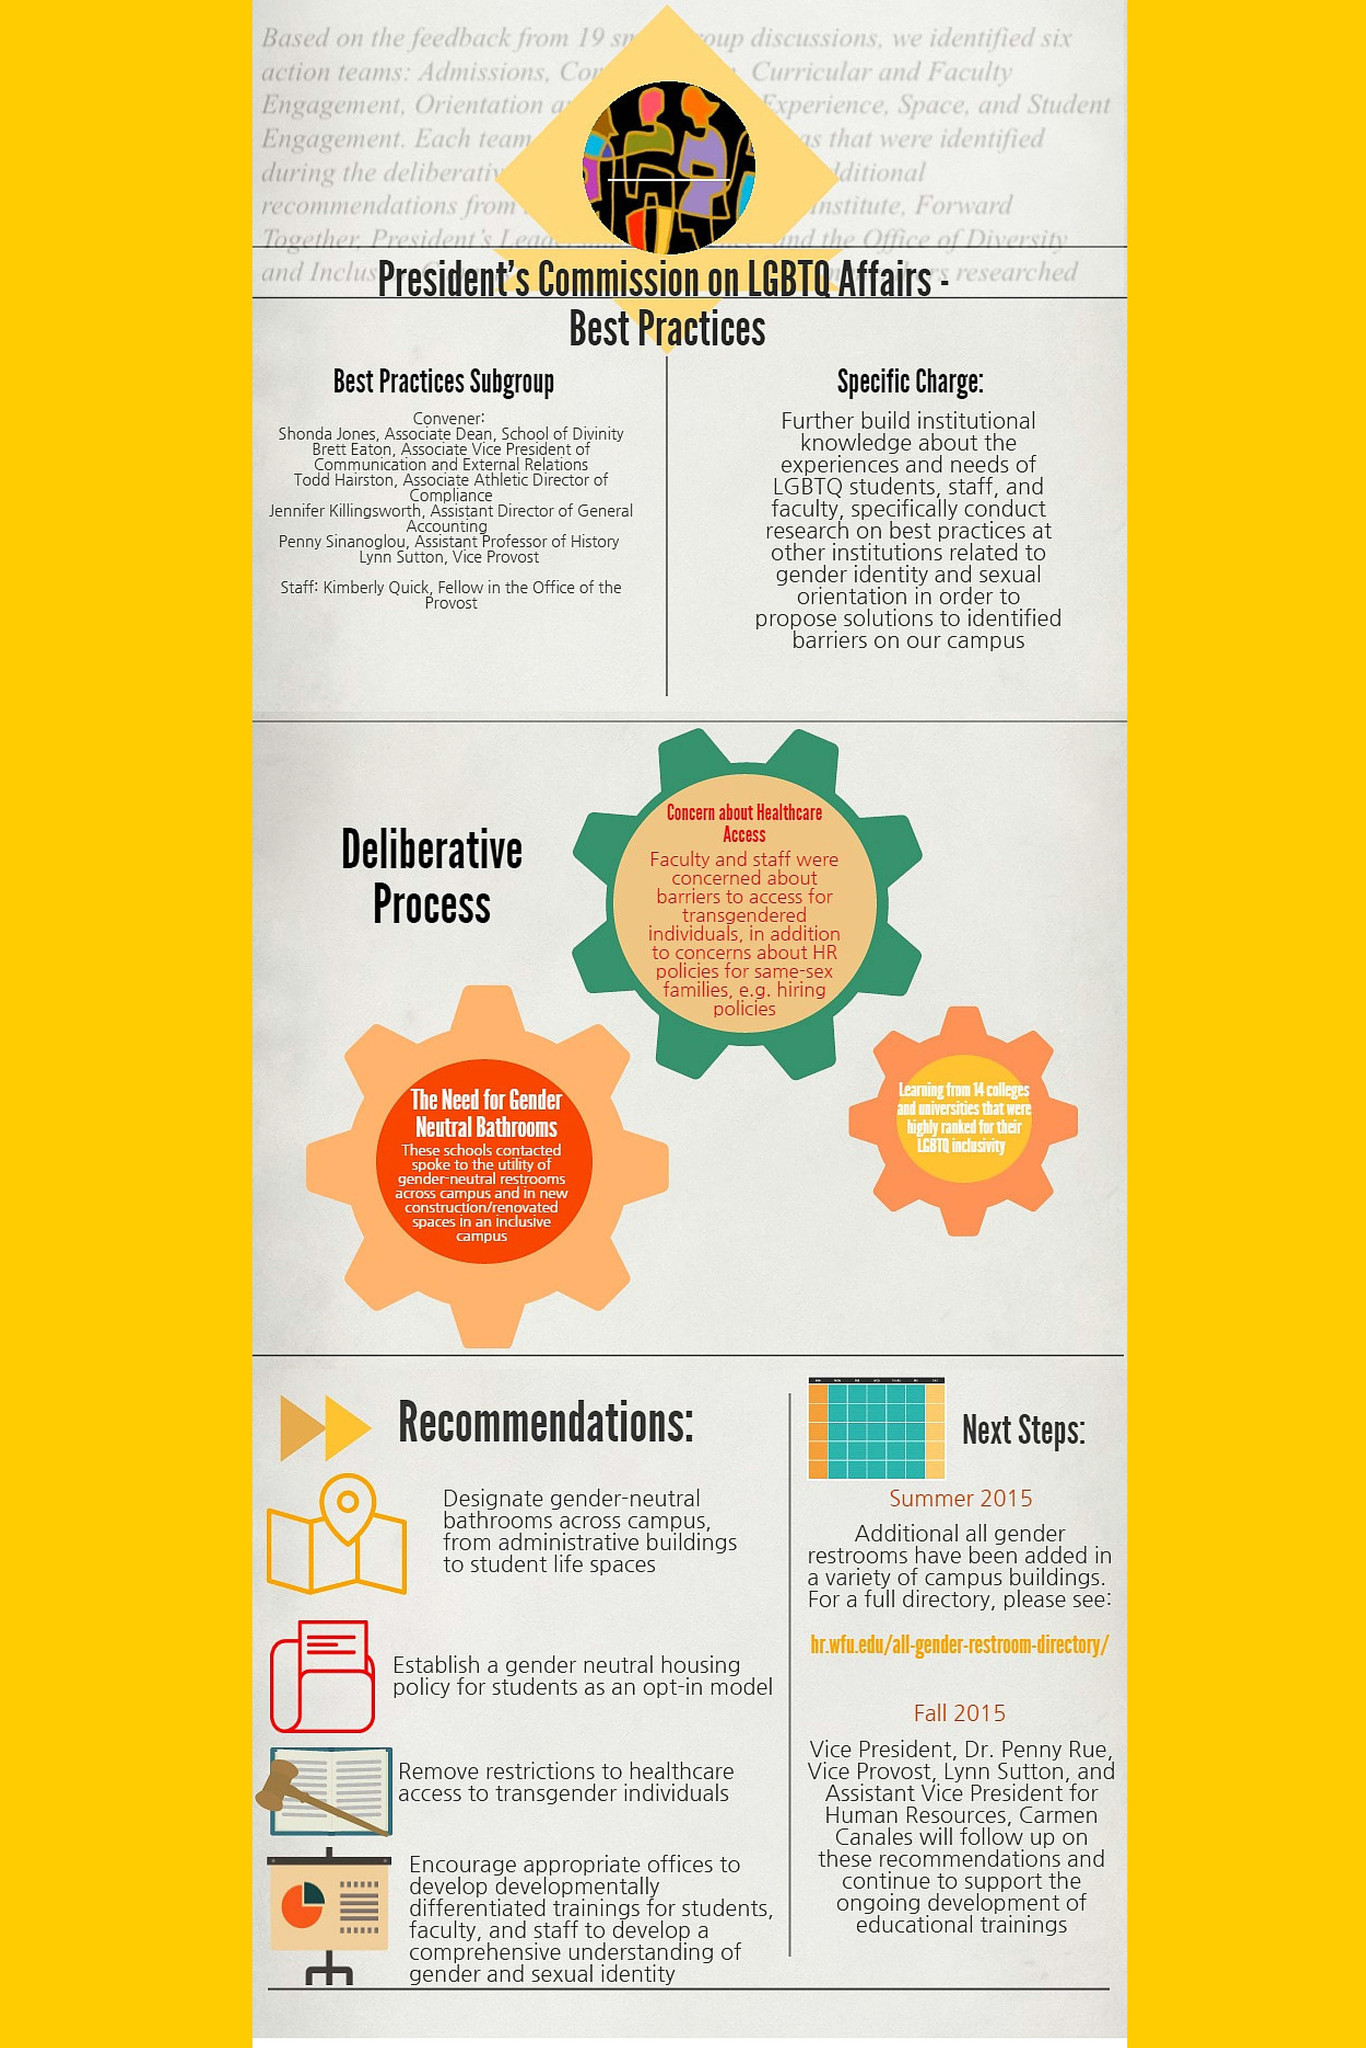how many recommendations have been mentioned
Answer the question with a short phrase. 4 when will follow up on recommendations be done fall 2015 how many deliberative process has been identified 3 When will additional all gender restrooms be added 2015 